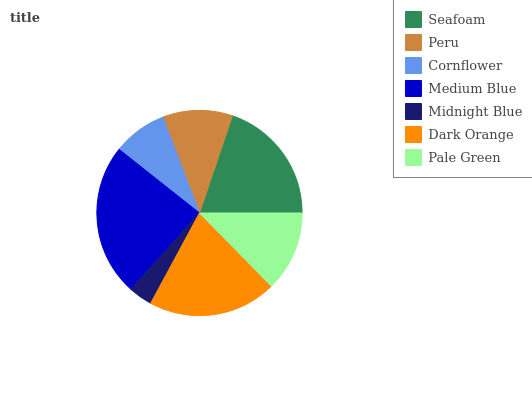Is Midnight Blue the minimum?
Answer yes or no. Yes. Is Medium Blue the maximum?
Answer yes or no. Yes. Is Peru the minimum?
Answer yes or no. No. Is Peru the maximum?
Answer yes or no. No. Is Seafoam greater than Peru?
Answer yes or no. Yes. Is Peru less than Seafoam?
Answer yes or no. Yes. Is Peru greater than Seafoam?
Answer yes or no. No. Is Seafoam less than Peru?
Answer yes or no. No. Is Pale Green the high median?
Answer yes or no. Yes. Is Pale Green the low median?
Answer yes or no. Yes. Is Midnight Blue the high median?
Answer yes or no. No. Is Medium Blue the low median?
Answer yes or no. No. 